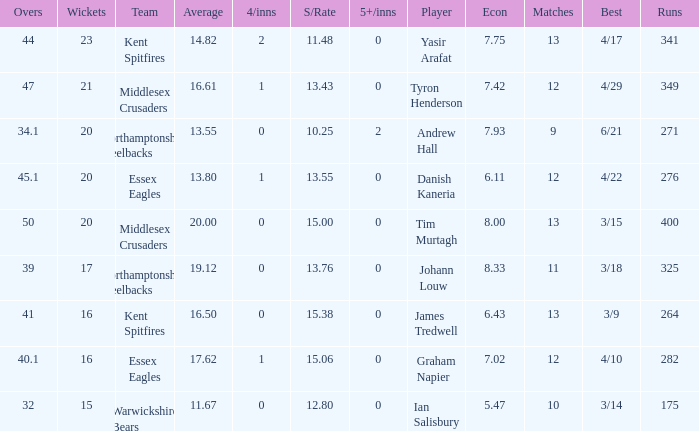Name the most 4/inns 2.0. 